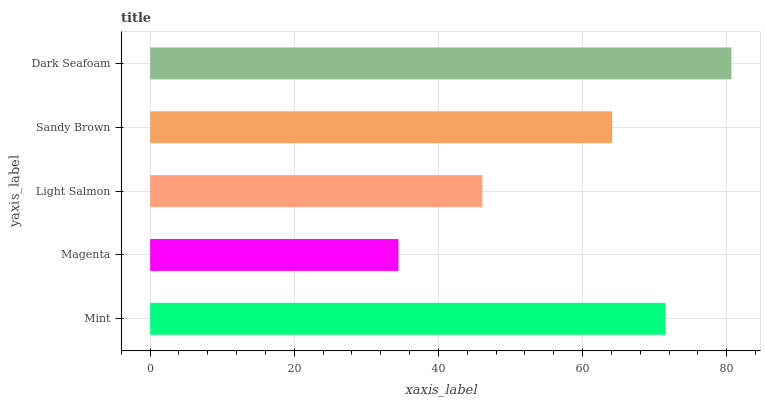Is Magenta the minimum?
Answer yes or no. Yes. Is Dark Seafoam the maximum?
Answer yes or no. Yes. Is Light Salmon the minimum?
Answer yes or no. No. Is Light Salmon the maximum?
Answer yes or no. No. Is Light Salmon greater than Magenta?
Answer yes or no. Yes. Is Magenta less than Light Salmon?
Answer yes or no. Yes. Is Magenta greater than Light Salmon?
Answer yes or no. No. Is Light Salmon less than Magenta?
Answer yes or no. No. Is Sandy Brown the high median?
Answer yes or no. Yes. Is Sandy Brown the low median?
Answer yes or no. Yes. Is Magenta the high median?
Answer yes or no. No. Is Mint the low median?
Answer yes or no. No. 